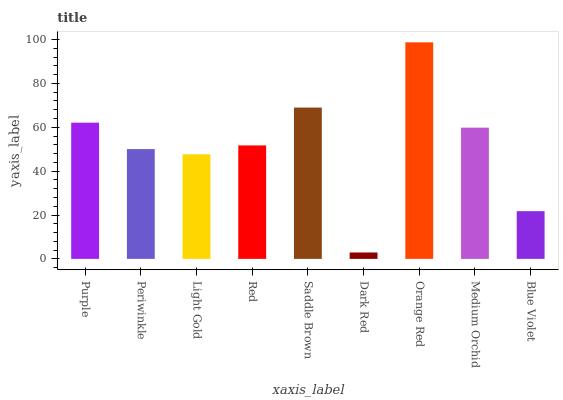Is Dark Red the minimum?
Answer yes or no. Yes. Is Orange Red the maximum?
Answer yes or no. Yes. Is Periwinkle the minimum?
Answer yes or no. No. Is Periwinkle the maximum?
Answer yes or no. No. Is Purple greater than Periwinkle?
Answer yes or no. Yes. Is Periwinkle less than Purple?
Answer yes or no. Yes. Is Periwinkle greater than Purple?
Answer yes or no. No. Is Purple less than Periwinkle?
Answer yes or no. No. Is Red the high median?
Answer yes or no. Yes. Is Red the low median?
Answer yes or no. Yes. Is Orange Red the high median?
Answer yes or no. No. Is Blue Violet the low median?
Answer yes or no. No. 